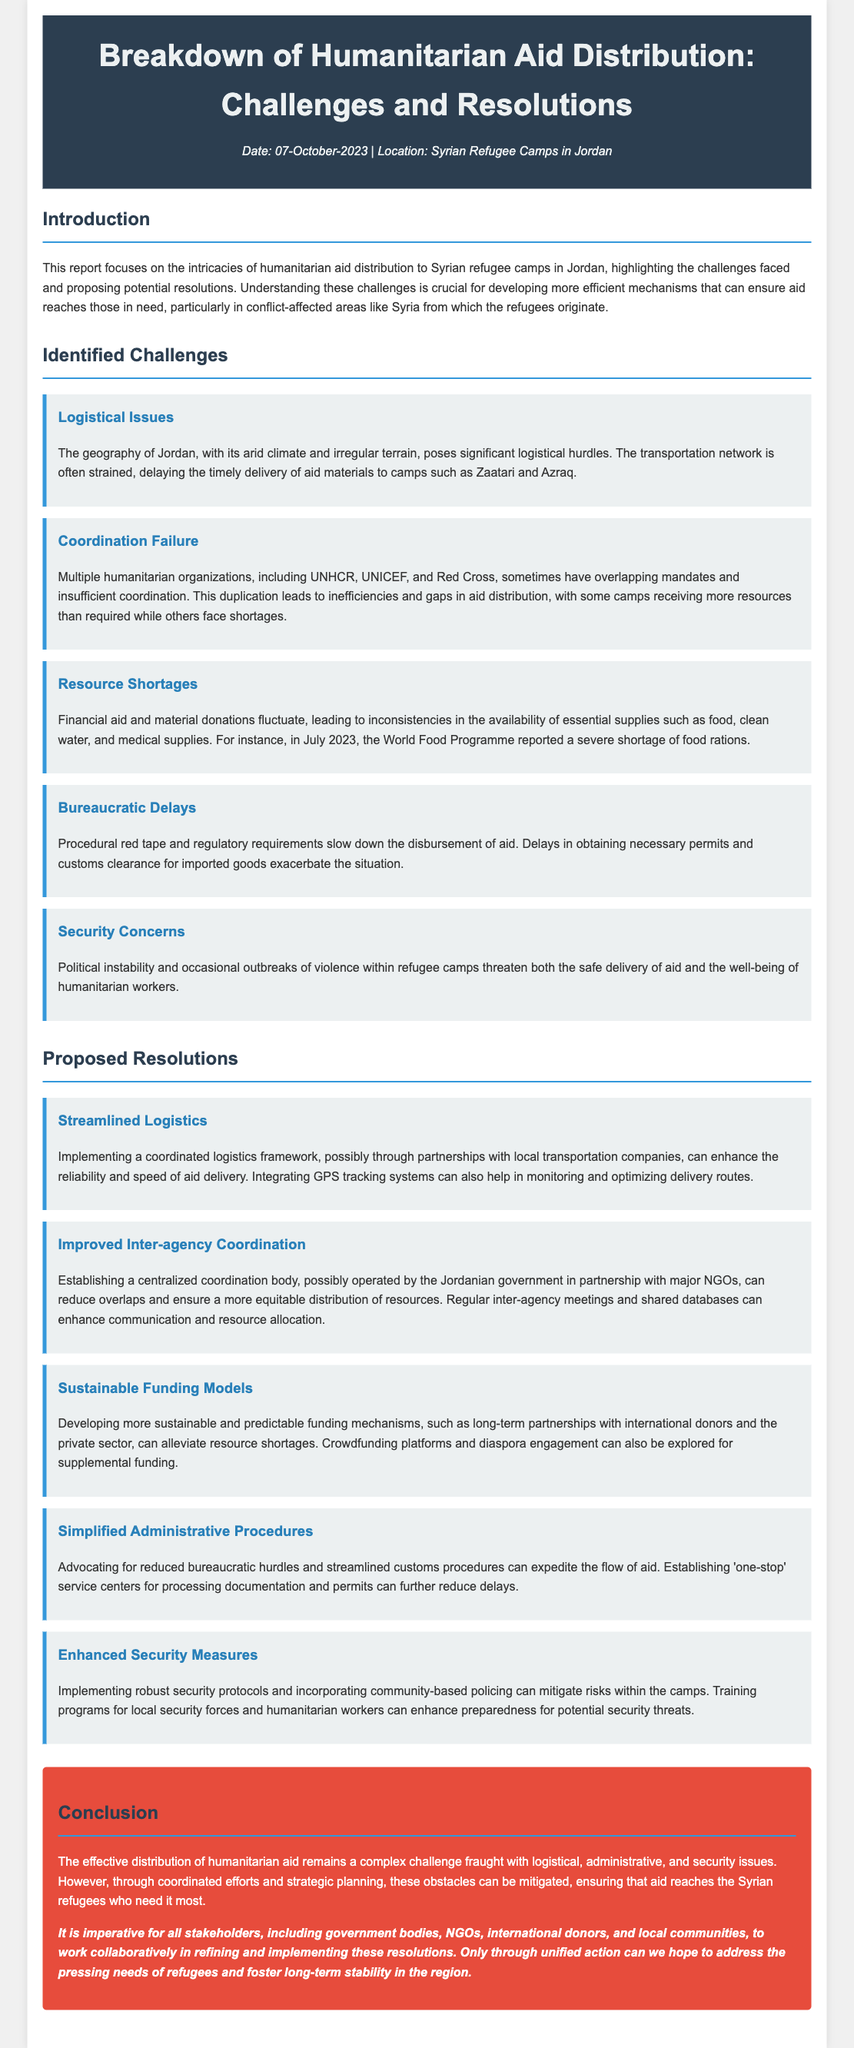What is the title of the report? The title of the report is mentioned in the header section of the document.
Answer: Breakdown of Humanitarian Aid Distribution: Challenges and Resolutions What date was the report published? The date is specified in the metadata of the document header.
Answer: 07-October-2023 What is one identified challenge related to logistics? The report lists specific logistical issues under the identified challenges section.
Answer: The geography of Jordan Which organization reported a shortage of food rations in July 2023? This information is provided under the resource shortages challenge.
Answer: World Food Programme What proposed resolution emphasizes improved inter-agency coordination? The resolution sections detail different proposals to address identified challenges.
Answer: Improved Inter-agency Coordination What security concern is mentioned in the report? Security concerns are highlighted in the identified challenges section.
Answer: Political instability How many proposed resolutions are listed in the report? The number of resolutions can be counted from the respective section in the document.
Answer: Five Which body is suggested to establish a centralized coordination for aid? The report suggests specific bodies to improve coordination in its proposed resolutions.
Answer: Jordanian government What is the main conclusion of the report? The conclusion summarizes the overall findings and implications within the document.
Answer: Complex challenge fraught with logistical, administrative, and security issues 